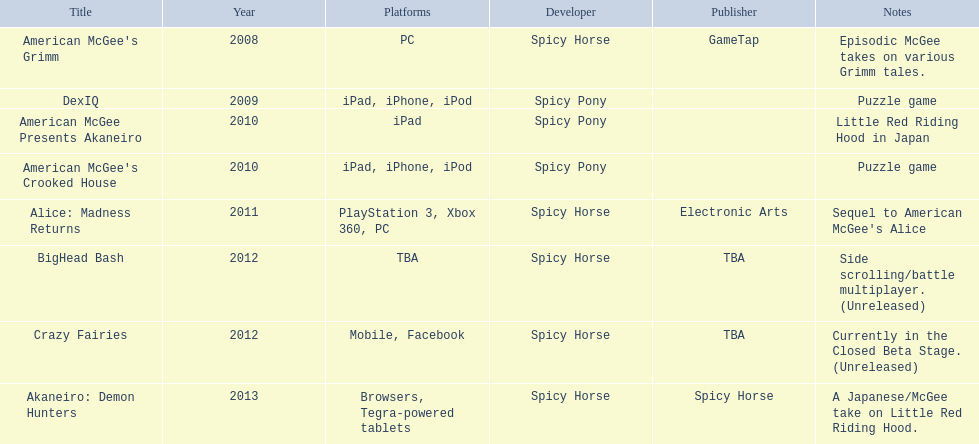What are the names of all published game titles? American McGee's Grimm, DexIQ, American McGee Presents Akaneiro, American McGee's Crooked House, Alice: Madness Returns, BigHead Bash, Crazy Fairies, Akaneiro: Demon Hunters. What are the identities of all the game publishers? GameTap, , , , Electronic Arts, TBA, TBA, Spicy Horse. What is the specific game title linked to electronic arts? Alice: Madness Returns. 